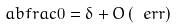Convert formula to latex. <formula><loc_0><loc_0><loc_500><loc_500>\ a b f r a c 0 = \delta + O \left ( \ e r r \right )</formula> 